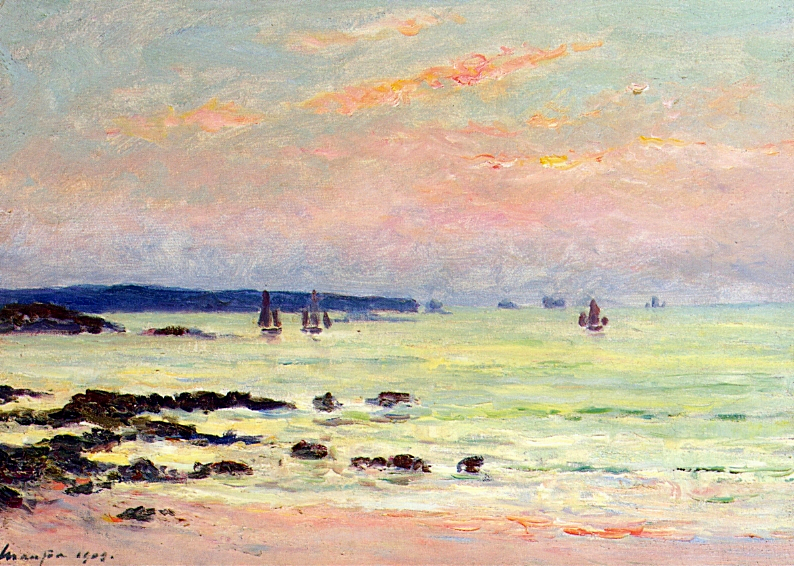Can you describe the technique used in this painting? Certainly! The painting showcases short, thick strokes of paint that capture the essence of the subject rather than the details, which is characteristic of the impressionist technique. The brushwork appears loose and free, conveying motion and the interplay of light with its surroundings. Individual colors are placed side by side with minimal mixing, allowing the viewer's eye to blend them at a distance and enhancing the vibrancy of the scene. 